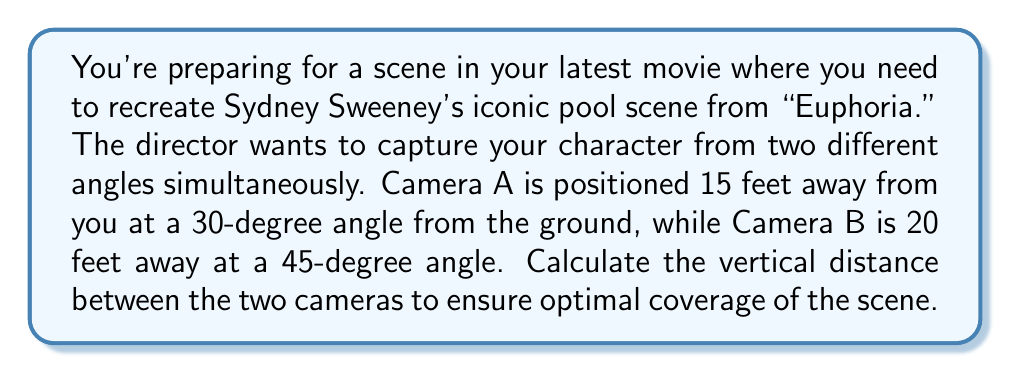Can you answer this question? Let's approach this step-by-step using trigonometry:

1) First, let's calculate the height of each camera:

   For Camera A:
   $\tan(30°) = \frac{h_A}{15}$
   $h_A = 15 \tan(30°) = 15 * 0.5774 = 8.66$ feet

   For Camera B:
   $\tan(45°) = \frac{h_B}{20}$
   $h_B = 20 \tan(45°) = 20 * 1 = 20$ feet

2) The vertical distance between the cameras is the difference in their heights:

   $\text{Vertical Distance} = h_B - h_A = 20 - 8.66 = 11.34$ feet

3) We can visualize this setup using the following diagram:

   [asy]
   import geometry;

   size(200);
   
   pair A = (0,0), B = (15,8.66), C = (20,20);
   
   draw(A--B--C--A);
   draw(B--(15,0), dashed);
   draw(C--(20,0), dashed);
   
   label("Ground", (10,-1), S);
   label("15 ft", (7.5,0), S);
   label("20 ft", (17.5,0), S);
   label("Camera A", B, NE);
   label("Camera B", C, NE);
   label("30°", A, NE);
   label("45°", A, SE);
   label("11.34 ft", (17.5,14.33), E);
   [/asy]

4) Round the result to two decimal places for practicality in set design.
Answer: 11.34 feet 